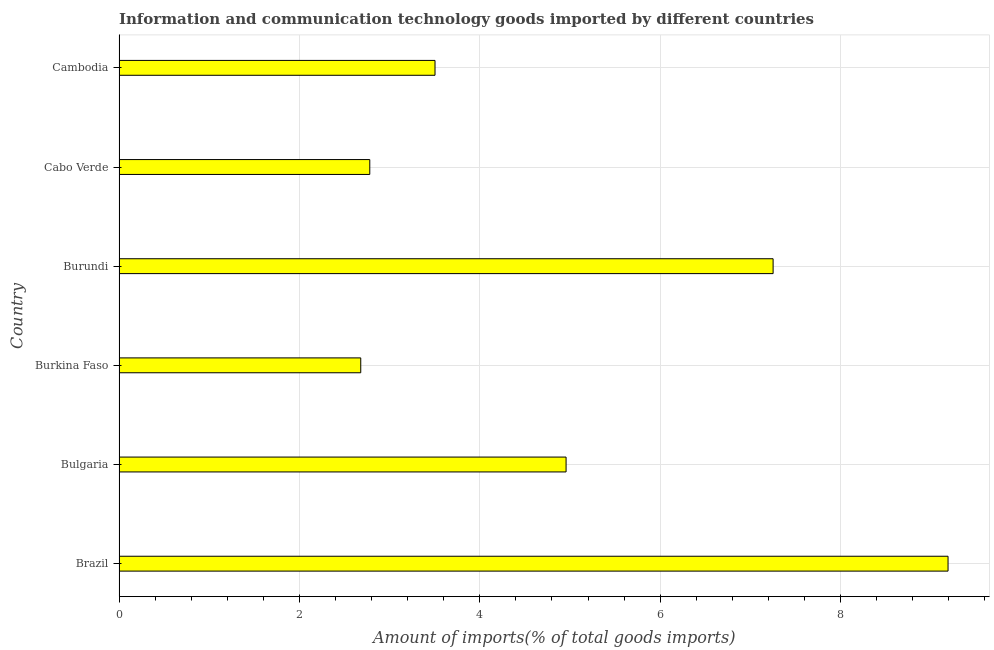Does the graph contain grids?
Provide a succinct answer. Yes. What is the title of the graph?
Your response must be concise. Information and communication technology goods imported by different countries. What is the label or title of the X-axis?
Offer a terse response. Amount of imports(% of total goods imports). What is the amount of ict goods imports in Cambodia?
Offer a very short reply. 3.5. Across all countries, what is the maximum amount of ict goods imports?
Provide a short and direct response. 9.19. Across all countries, what is the minimum amount of ict goods imports?
Offer a very short reply. 2.68. In which country was the amount of ict goods imports maximum?
Your response must be concise. Brazil. In which country was the amount of ict goods imports minimum?
Your answer should be compact. Burkina Faso. What is the sum of the amount of ict goods imports?
Offer a terse response. 30.36. What is the difference between the amount of ict goods imports in Brazil and Cambodia?
Make the answer very short. 5.69. What is the average amount of ict goods imports per country?
Offer a terse response. 5.06. What is the median amount of ict goods imports?
Ensure brevity in your answer.  4.23. In how many countries, is the amount of ict goods imports greater than 9.2 %?
Ensure brevity in your answer.  0. What is the ratio of the amount of ict goods imports in Bulgaria to that in Cabo Verde?
Keep it short and to the point. 1.78. What is the difference between the highest and the second highest amount of ict goods imports?
Provide a succinct answer. 1.94. What is the difference between the highest and the lowest amount of ict goods imports?
Your answer should be compact. 6.51. In how many countries, is the amount of ict goods imports greater than the average amount of ict goods imports taken over all countries?
Provide a succinct answer. 2. How many bars are there?
Keep it short and to the point. 6. How many countries are there in the graph?
Your response must be concise. 6. What is the Amount of imports(% of total goods imports) of Brazil?
Provide a short and direct response. 9.19. What is the Amount of imports(% of total goods imports) in Bulgaria?
Keep it short and to the point. 4.96. What is the Amount of imports(% of total goods imports) of Burkina Faso?
Your response must be concise. 2.68. What is the Amount of imports(% of total goods imports) of Burundi?
Your answer should be very brief. 7.25. What is the Amount of imports(% of total goods imports) in Cabo Verde?
Provide a short and direct response. 2.78. What is the Amount of imports(% of total goods imports) in Cambodia?
Your answer should be very brief. 3.5. What is the difference between the Amount of imports(% of total goods imports) in Brazil and Bulgaria?
Provide a short and direct response. 4.24. What is the difference between the Amount of imports(% of total goods imports) in Brazil and Burkina Faso?
Offer a very short reply. 6.51. What is the difference between the Amount of imports(% of total goods imports) in Brazil and Burundi?
Make the answer very short. 1.94. What is the difference between the Amount of imports(% of total goods imports) in Brazil and Cabo Verde?
Make the answer very short. 6.41. What is the difference between the Amount of imports(% of total goods imports) in Brazil and Cambodia?
Provide a short and direct response. 5.69. What is the difference between the Amount of imports(% of total goods imports) in Bulgaria and Burkina Faso?
Keep it short and to the point. 2.28. What is the difference between the Amount of imports(% of total goods imports) in Bulgaria and Burundi?
Offer a very short reply. -2.3. What is the difference between the Amount of imports(% of total goods imports) in Bulgaria and Cabo Verde?
Provide a short and direct response. 2.18. What is the difference between the Amount of imports(% of total goods imports) in Bulgaria and Cambodia?
Offer a terse response. 1.45. What is the difference between the Amount of imports(% of total goods imports) in Burkina Faso and Burundi?
Keep it short and to the point. -4.57. What is the difference between the Amount of imports(% of total goods imports) in Burkina Faso and Cabo Verde?
Your answer should be very brief. -0.1. What is the difference between the Amount of imports(% of total goods imports) in Burkina Faso and Cambodia?
Your answer should be very brief. -0.82. What is the difference between the Amount of imports(% of total goods imports) in Burundi and Cabo Verde?
Make the answer very short. 4.47. What is the difference between the Amount of imports(% of total goods imports) in Burundi and Cambodia?
Ensure brevity in your answer.  3.75. What is the difference between the Amount of imports(% of total goods imports) in Cabo Verde and Cambodia?
Your answer should be very brief. -0.72. What is the ratio of the Amount of imports(% of total goods imports) in Brazil to that in Bulgaria?
Give a very brief answer. 1.85. What is the ratio of the Amount of imports(% of total goods imports) in Brazil to that in Burkina Faso?
Provide a succinct answer. 3.43. What is the ratio of the Amount of imports(% of total goods imports) in Brazil to that in Burundi?
Your response must be concise. 1.27. What is the ratio of the Amount of imports(% of total goods imports) in Brazil to that in Cabo Verde?
Provide a succinct answer. 3.31. What is the ratio of the Amount of imports(% of total goods imports) in Brazil to that in Cambodia?
Your answer should be very brief. 2.62. What is the ratio of the Amount of imports(% of total goods imports) in Bulgaria to that in Burkina Faso?
Offer a very short reply. 1.85. What is the ratio of the Amount of imports(% of total goods imports) in Bulgaria to that in Burundi?
Give a very brief answer. 0.68. What is the ratio of the Amount of imports(% of total goods imports) in Bulgaria to that in Cabo Verde?
Give a very brief answer. 1.78. What is the ratio of the Amount of imports(% of total goods imports) in Bulgaria to that in Cambodia?
Your response must be concise. 1.42. What is the ratio of the Amount of imports(% of total goods imports) in Burkina Faso to that in Burundi?
Keep it short and to the point. 0.37. What is the ratio of the Amount of imports(% of total goods imports) in Burkina Faso to that in Cabo Verde?
Your answer should be compact. 0.96. What is the ratio of the Amount of imports(% of total goods imports) in Burkina Faso to that in Cambodia?
Offer a very short reply. 0.77. What is the ratio of the Amount of imports(% of total goods imports) in Burundi to that in Cabo Verde?
Make the answer very short. 2.61. What is the ratio of the Amount of imports(% of total goods imports) in Burundi to that in Cambodia?
Your answer should be compact. 2.07. What is the ratio of the Amount of imports(% of total goods imports) in Cabo Verde to that in Cambodia?
Keep it short and to the point. 0.79. 